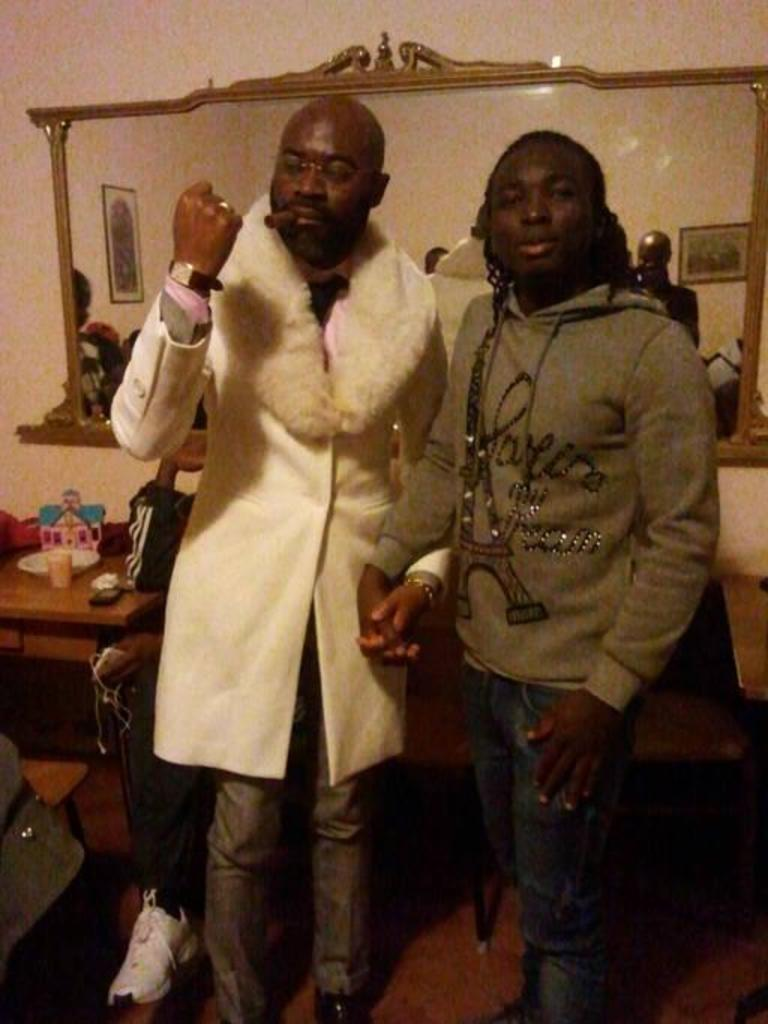How many men are present in the image? There are two men standing in the image. What surface are the men standing on? The men are standing on the floor. What can be seen in the background of the image? There are chairs, a mirrored surface, a wall, frames, and other objects in the background of the image. Can you see the waves crashing on the shore in the image? There are no waves or shore visible in the image; it features two men standing on the floor with various objects in the background. 